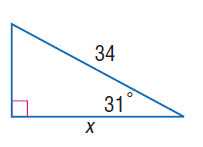Question: Find x.
Choices:
A. 7.3
B. 25.8
C. 29.1
D. 33.4
Answer with the letter. Answer: C 